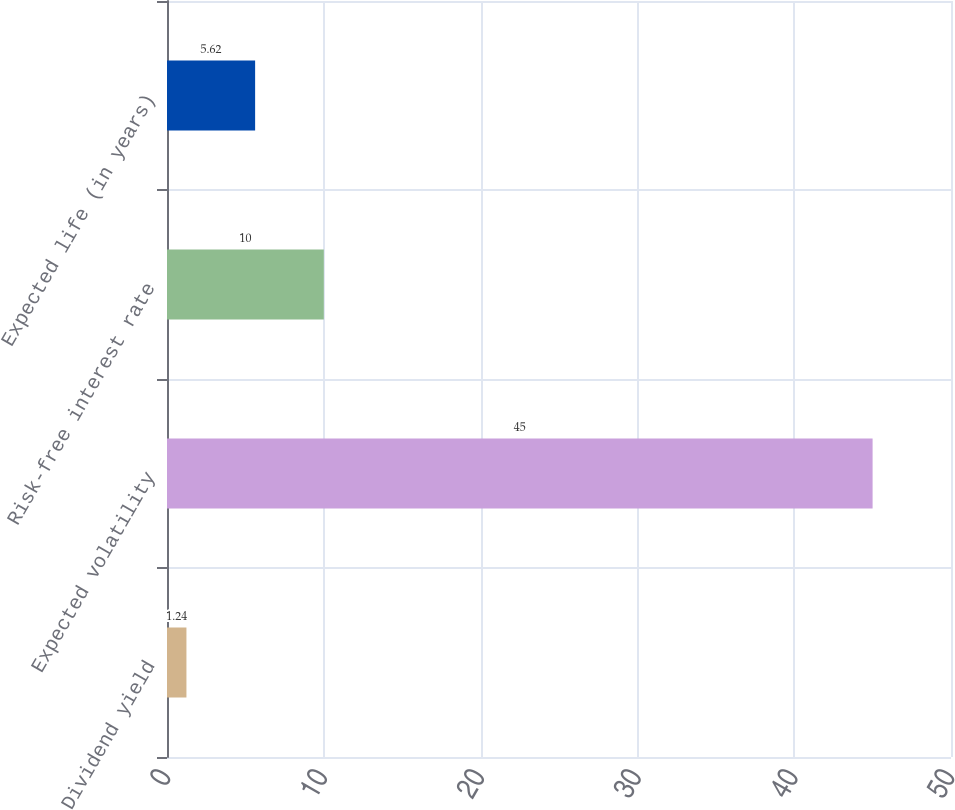Convert chart to OTSL. <chart><loc_0><loc_0><loc_500><loc_500><bar_chart><fcel>Dividend yield<fcel>Expected volatility<fcel>Risk-free interest rate<fcel>Expected life (in years)<nl><fcel>1.24<fcel>45<fcel>10<fcel>5.62<nl></chart> 